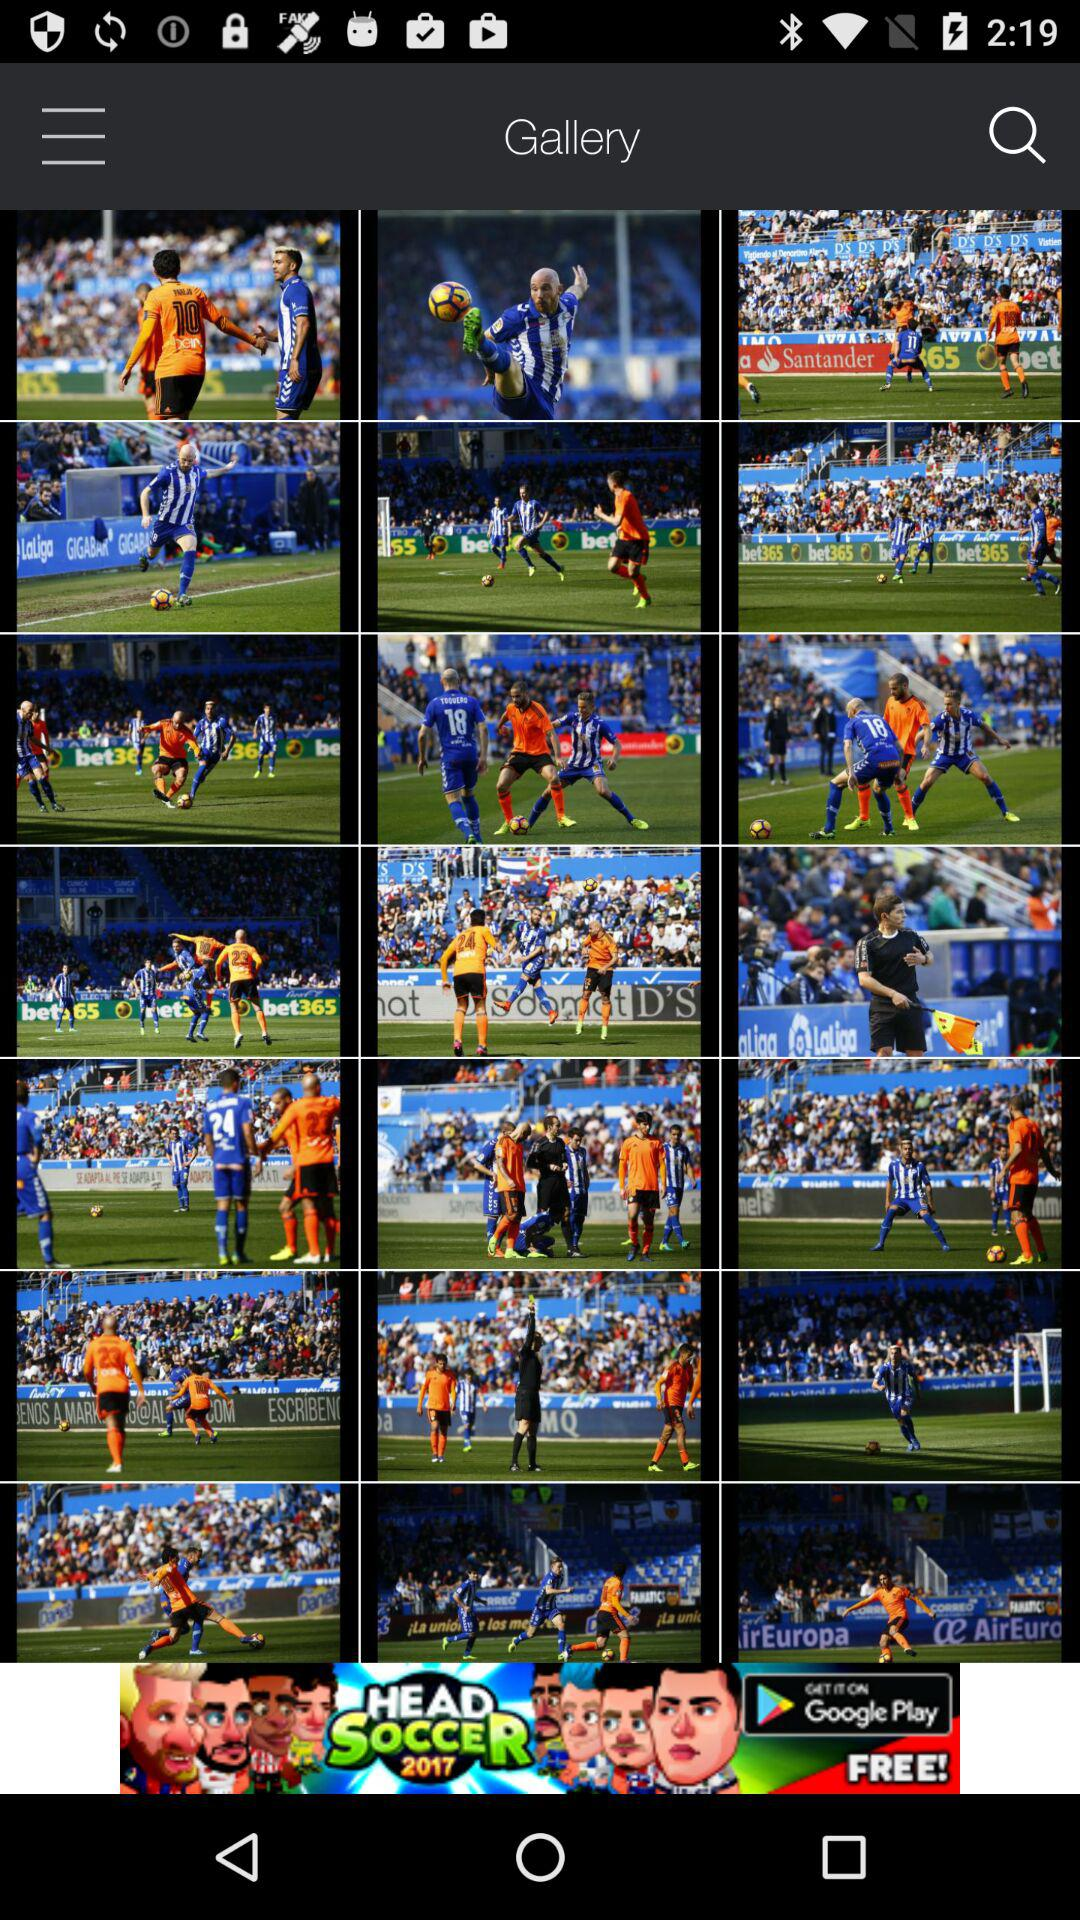What are the names of the images in the gallery?
When the provided information is insufficient, respond with <no answer>. <no answer> 